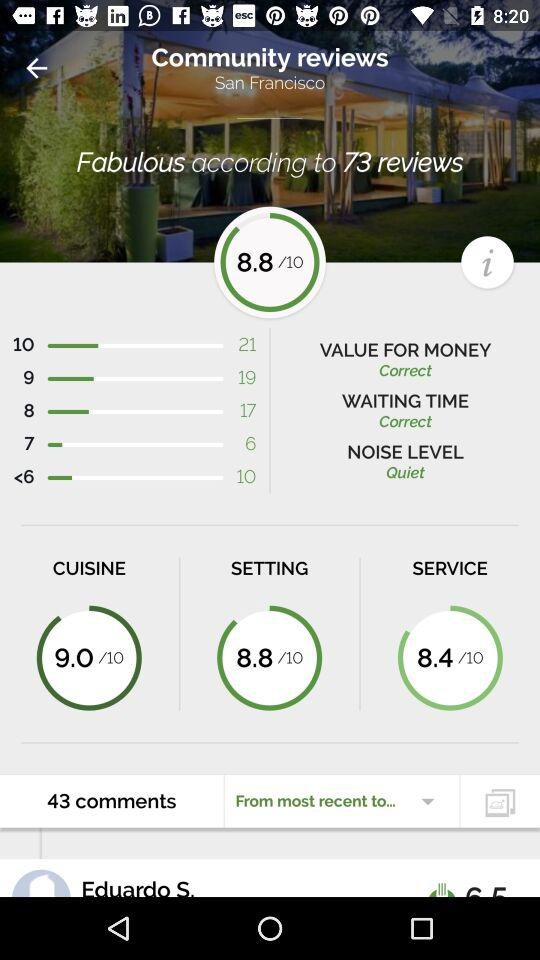What's the total number of comments? The total number of comments is 43. 